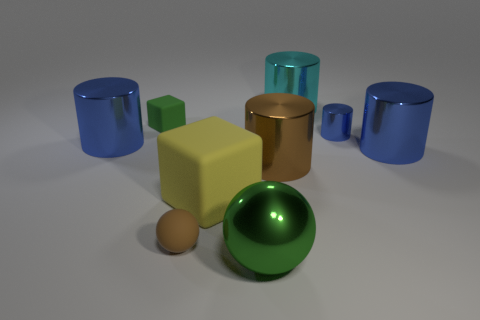Add 1 big blue metal cylinders. How many objects exist? 10 Subtract all tiny blue shiny cylinders. How many cylinders are left? 4 Subtract all brown cylinders. How many cylinders are left? 4 Subtract all green cubes. How many blue cylinders are left? 3 Subtract 1 cubes. How many cubes are left? 1 Subtract all red balls. Subtract all gray cubes. How many balls are left? 2 Subtract all small blue metal objects. Subtract all cyan metal cylinders. How many objects are left? 7 Add 7 small matte spheres. How many small matte spheres are left? 8 Add 4 green metal blocks. How many green metal blocks exist? 4 Subtract 1 yellow cubes. How many objects are left? 8 